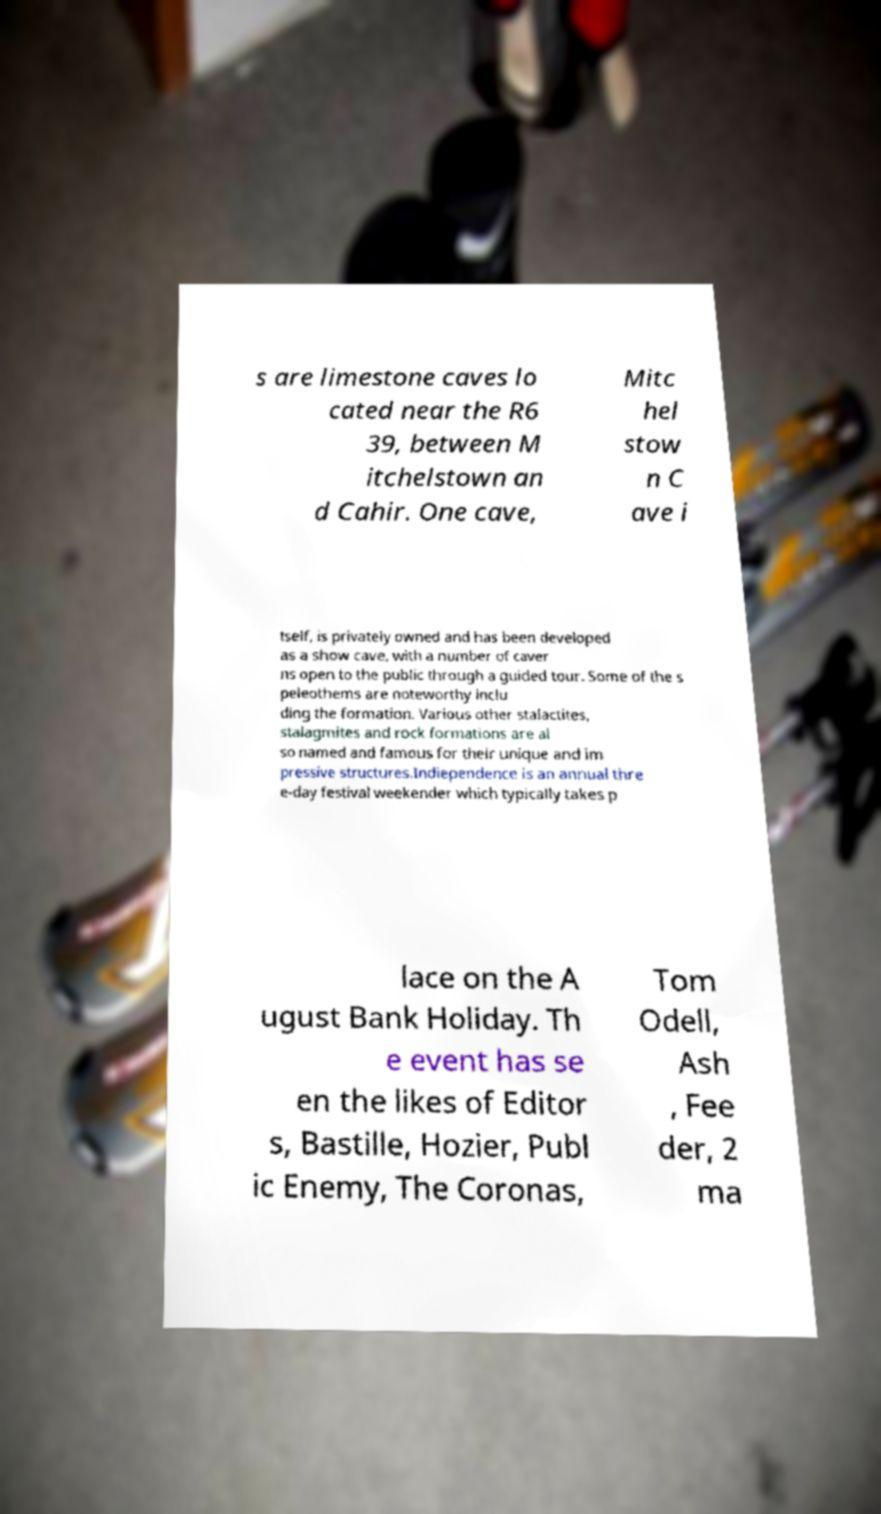For documentation purposes, I need the text within this image transcribed. Could you provide that? s are limestone caves lo cated near the R6 39, between M itchelstown an d Cahir. One cave, Mitc hel stow n C ave i tself, is privately owned and has been developed as a show cave, with a number of caver ns open to the public through a guided tour. Some of the s peleothems are noteworthy inclu ding the formation. Various other stalactites, stalagmites and rock formations are al so named and famous for their unique and im pressive structures.Indiependence is an annual thre e-day festival weekender which typically takes p lace on the A ugust Bank Holiday. Th e event has se en the likes of Editor s, Bastille, Hozier, Publ ic Enemy, The Coronas, Tom Odell, Ash , Fee der, 2 ma 